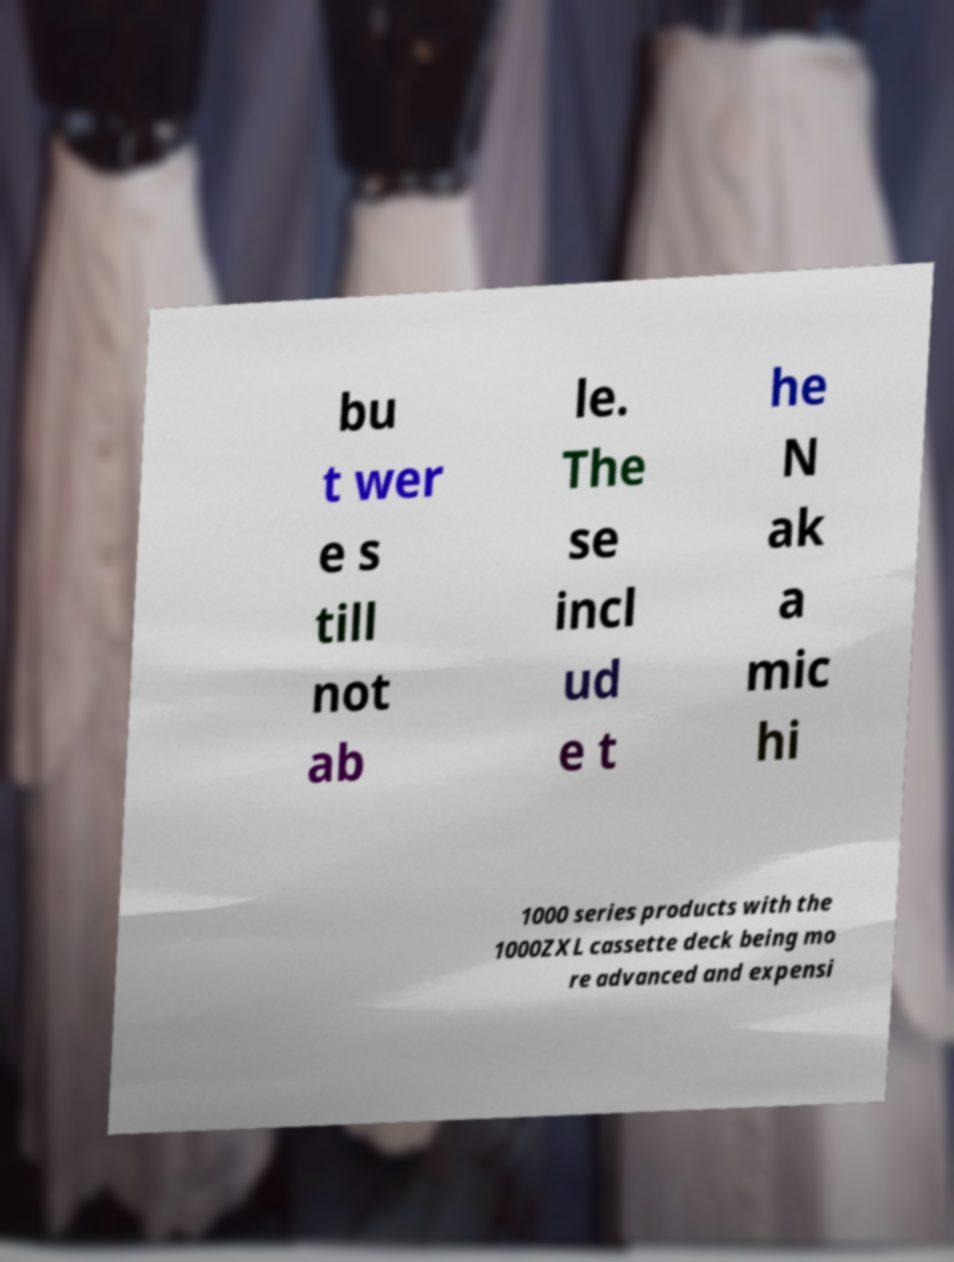What messages or text are displayed in this image? I need them in a readable, typed format. bu t wer e s till not ab le. The se incl ud e t he N ak a mic hi 1000 series products with the 1000ZXL cassette deck being mo re advanced and expensi 